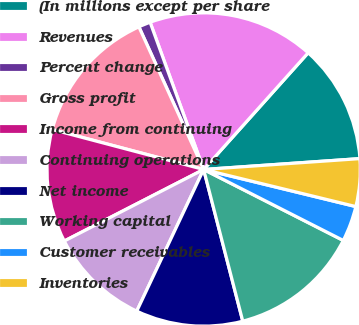Convert chart. <chart><loc_0><loc_0><loc_500><loc_500><pie_chart><fcel>(In millions except per share<fcel>Revenues<fcel>Percent change<fcel>Gross profit<fcel>Income from continuing<fcel>Continuing operations<fcel>Net income<fcel>Working capital<fcel>Customer receivables<fcel>Inventories<nl><fcel>12.27%<fcel>17.18%<fcel>1.23%<fcel>14.11%<fcel>11.66%<fcel>10.43%<fcel>11.04%<fcel>13.5%<fcel>3.68%<fcel>4.91%<nl></chart> 